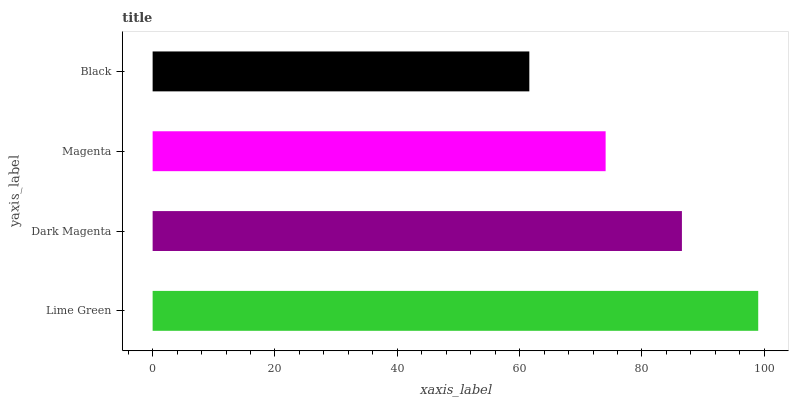Is Black the minimum?
Answer yes or no. Yes. Is Lime Green the maximum?
Answer yes or no. Yes. Is Dark Magenta the minimum?
Answer yes or no. No. Is Dark Magenta the maximum?
Answer yes or no. No. Is Lime Green greater than Dark Magenta?
Answer yes or no. Yes. Is Dark Magenta less than Lime Green?
Answer yes or no. Yes. Is Dark Magenta greater than Lime Green?
Answer yes or no. No. Is Lime Green less than Dark Magenta?
Answer yes or no. No. Is Dark Magenta the high median?
Answer yes or no. Yes. Is Magenta the low median?
Answer yes or no. Yes. Is Magenta the high median?
Answer yes or no. No. Is Dark Magenta the low median?
Answer yes or no. No. 